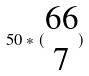Convert formula to latex. <formula><loc_0><loc_0><loc_500><loc_500>5 0 * ( \begin{matrix} 6 6 \\ 7 \end{matrix} )</formula> 